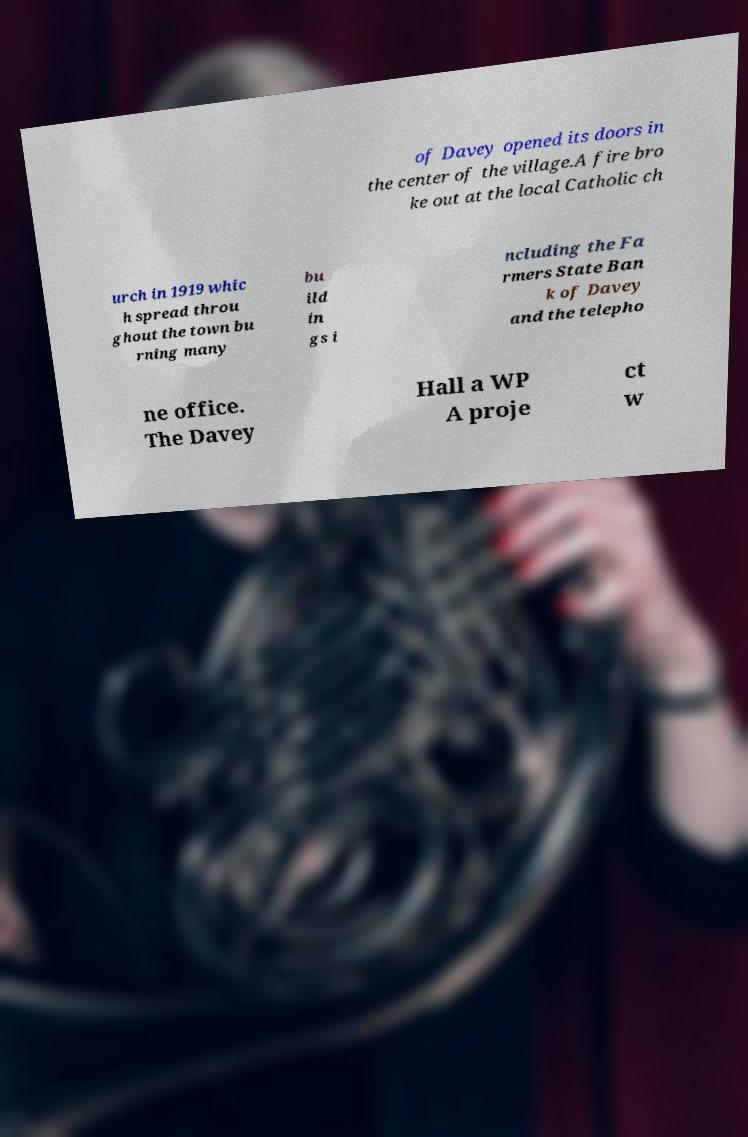I need the written content from this picture converted into text. Can you do that? of Davey opened its doors in the center of the village.A fire bro ke out at the local Catholic ch urch in 1919 whic h spread throu ghout the town bu rning many bu ild in gs i ncluding the Fa rmers State Ban k of Davey and the telepho ne office. The Davey Hall a WP A proje ct w 